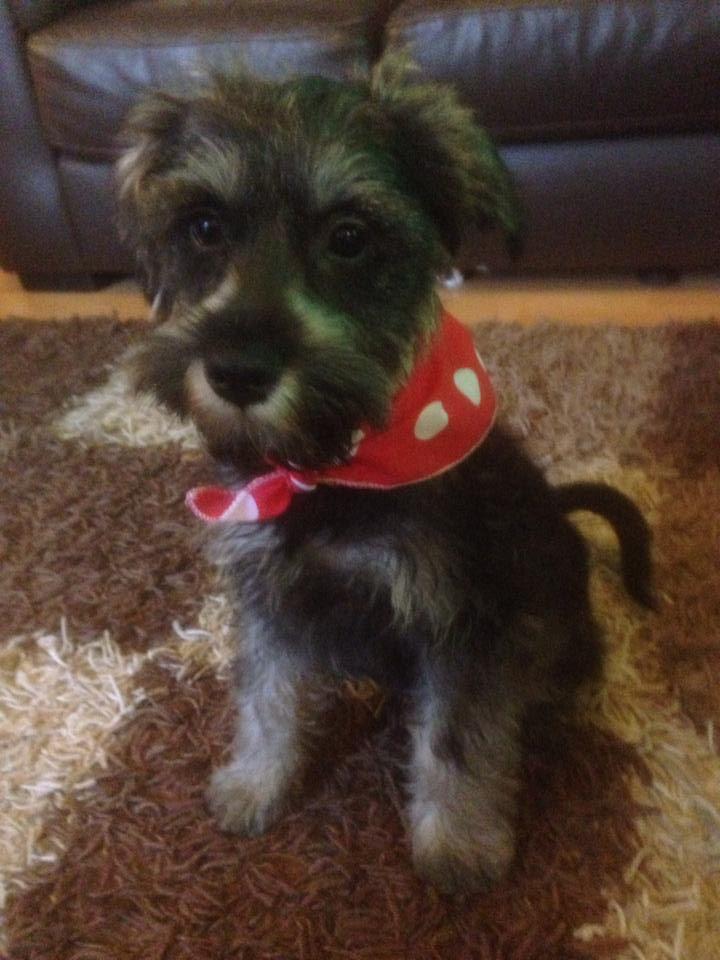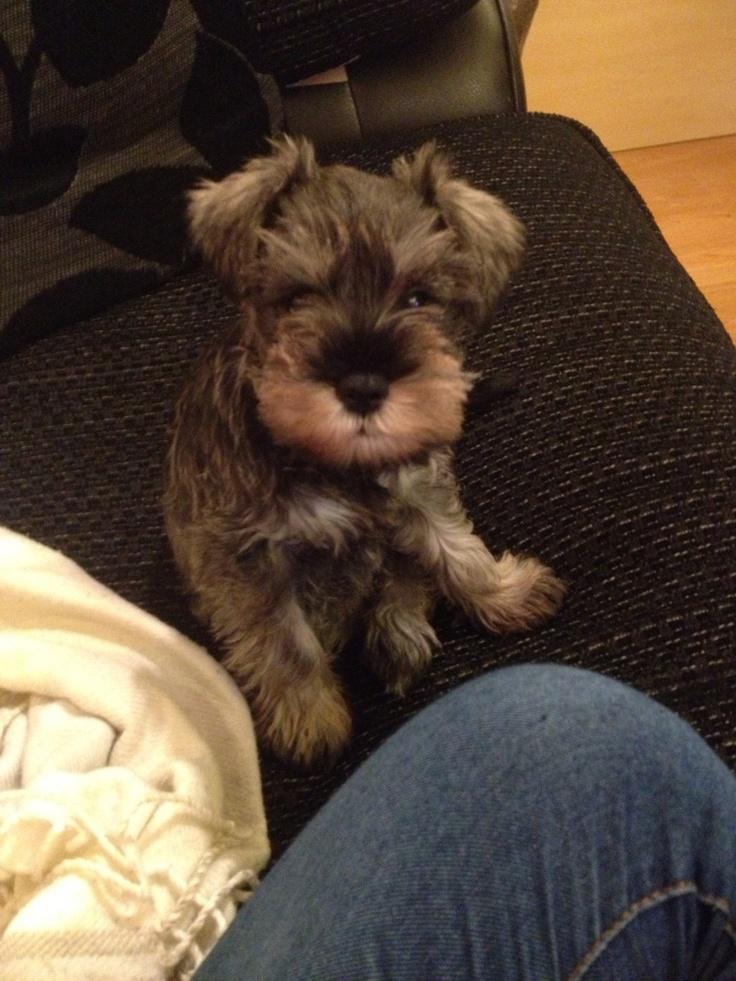The first image is the image on the left, the second image is the image on the right. Considering the images on both sides, is "One of the dogs is next to a human, and at least one of the dogs is close to a couch." valid? Answer yes or no. Yes. The first image is the image on the left, the second image is the image on the right. For the images displayed, is the sentence "Part of a human limb is visible in an image containing one small schnauzer dog." factually correct? Answer yes or no. Yes. 